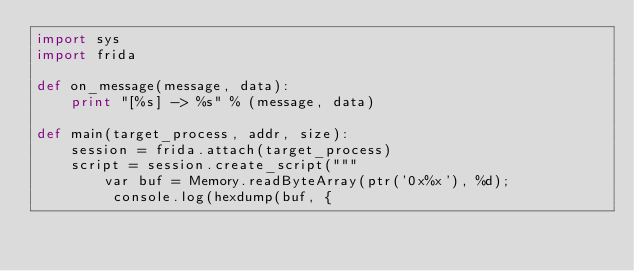Convert code to text. <code><loc_0><loc_0><loc_500><loc_500><_Python_>import sys
import frida

def on_message(message, data):
	print "[%s] -> %s" % (message, data)

def main(target_process, addr, size):
	session = frida.attach(target_process)
	script = session.create_script("""
		var buf = Memory.readByteArray(ptr('0x%x'), %d);
		 console.log(hexdump(buf, {</code> 